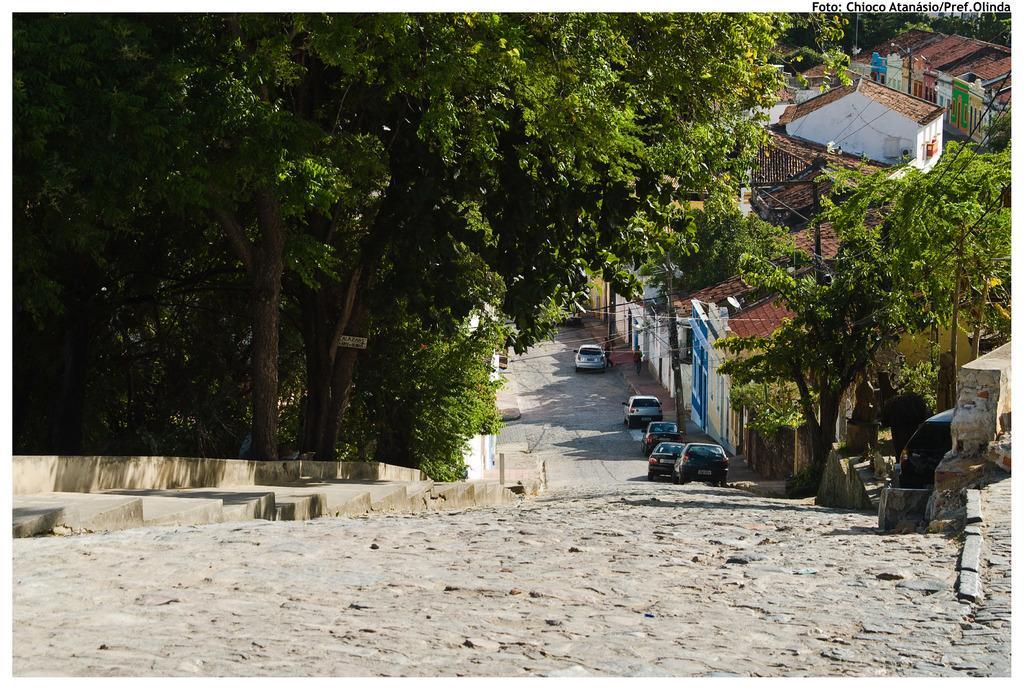Please provide a concise description of this image. In this picture we can see the trees, houses, rooftops, people, vehicles and the poles. At the bottom portion of the picture we can see the road. On the left side we can see the stairs. In the top right corner of the picture we can see watermark. 